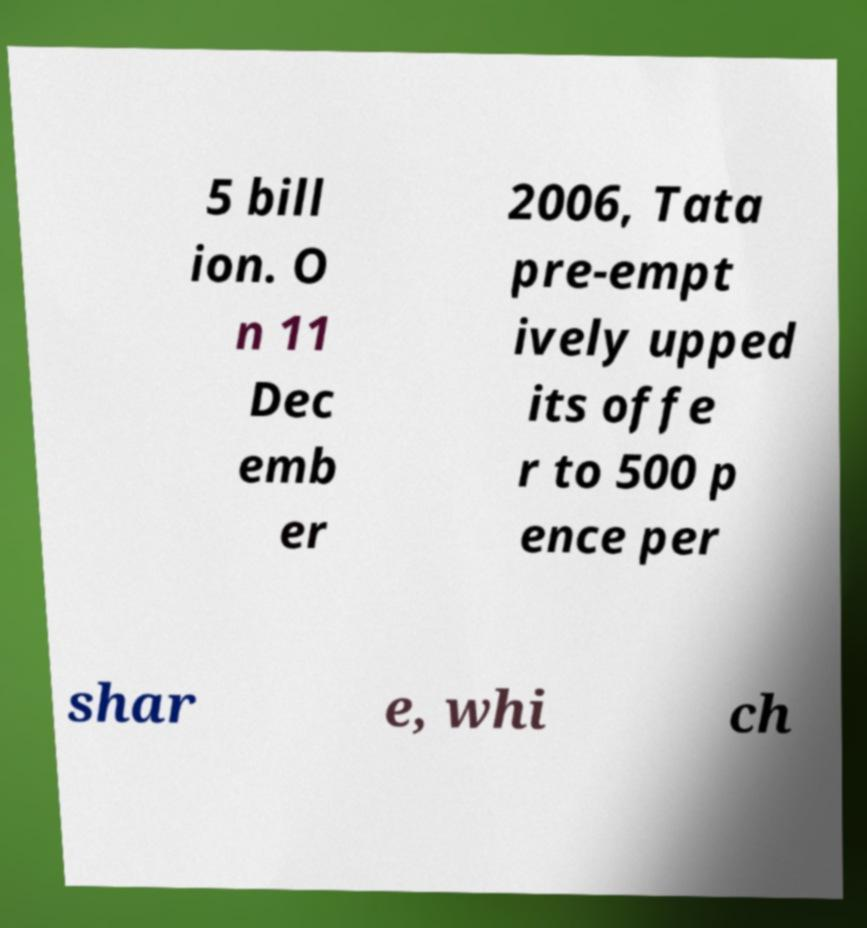Could you extract and type out the text from this image? 5 bill ion. O n 11 Dec emb er 2006, Tata pre-empt ively upped its offe r to 500 p ence per shar e, whi ch 